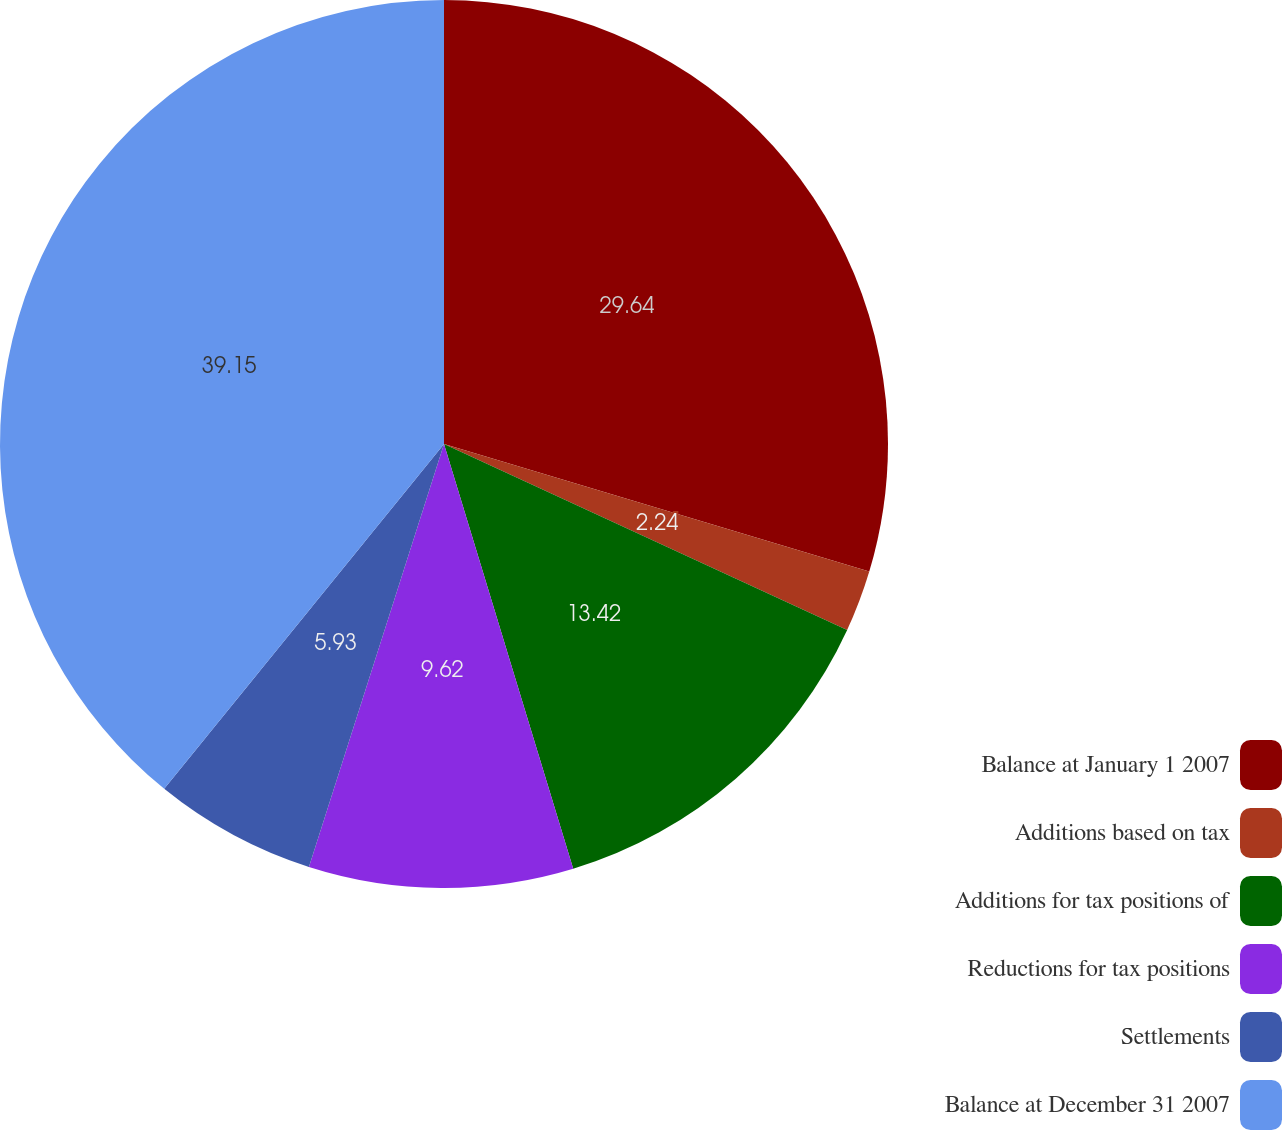<chart> <loc_0><loc_0><loc_500><loc_500><pie_chart><fcel>Balance at January 1 2007<fcel>Additions based on tax<fcel>Additions for tax positions of<fcel>Reductions for tax positions<fcel>Settlements<fcel>Balance at December 31 2007<nl><fcel>29.64%<fcel>2.24%<fcel>13.42%<fcel>9.62%<fcel>5.93%<fcel>39.15%<nl></chart> 